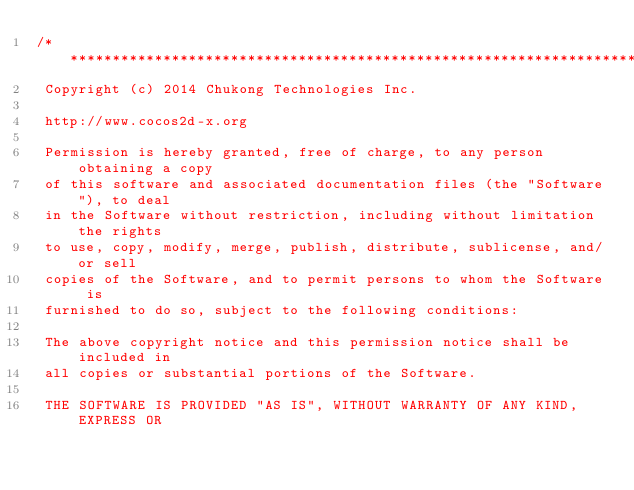Convert code to text. <code><loc_0><loc_0><loc_500><loc_500><_C_>/****************************************************************************
 Copyright (c) 2014 Chukong Technologies Inc.
 
 http://www.cocos2d-x.org
 
 Permission is hereby granted, free of charge, to any person obtaining a copy
 of this software and associated documentation files (the "Software"), to deal
 in the Software without restriction, including without limitation the rights
 to use, copy, modify, merge, publish, distribute, sublicense, and/or sell
 copies of the Software, and to permit persons to whom the Software is
 furnished to do so, subject to the following conditions:
 
 The above copyright notice and this permission notice shall be included in
 all copies or substantial portions of the Software.
 
 THE SOFTWARE IS PROVIDED "AS IS", WITHOUT WARRANTY OF ANY KIND, EXPRESS OR</code> 